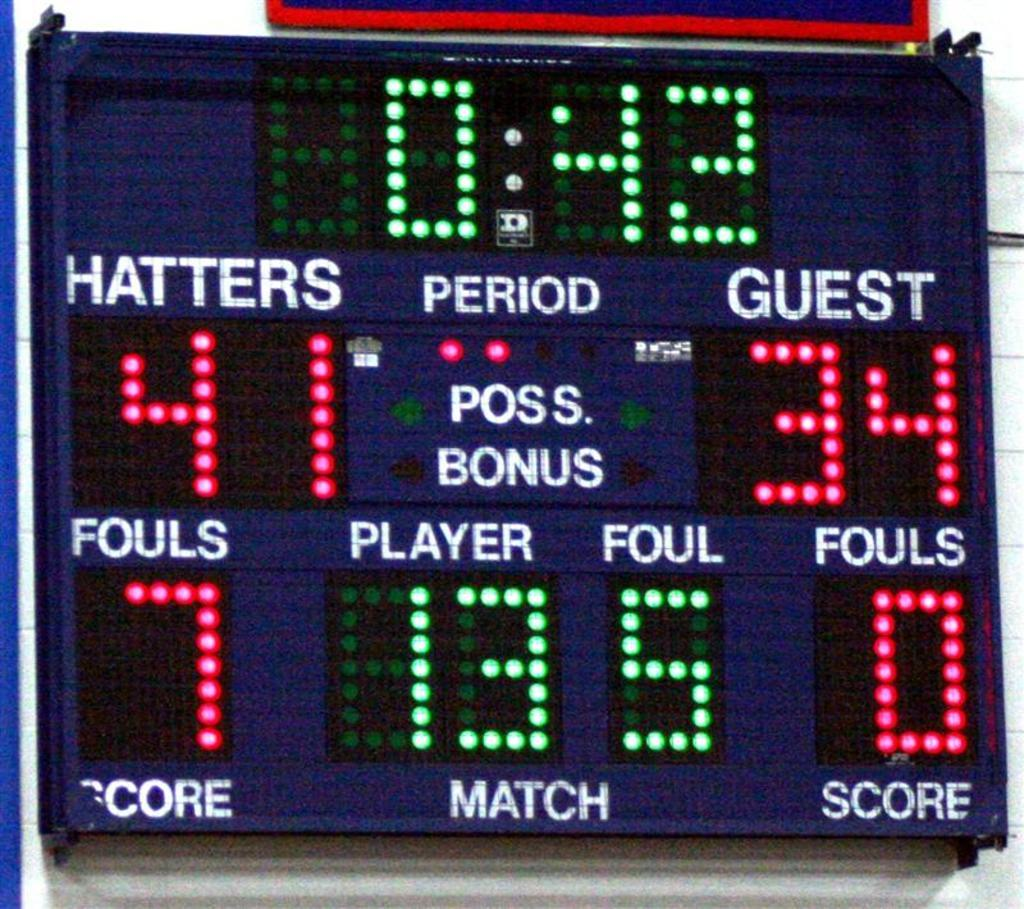<image>
Offer a succinct explanation of the picture presented. blue scoreboard showing the hatters ahead of guest team in the 2nd period 